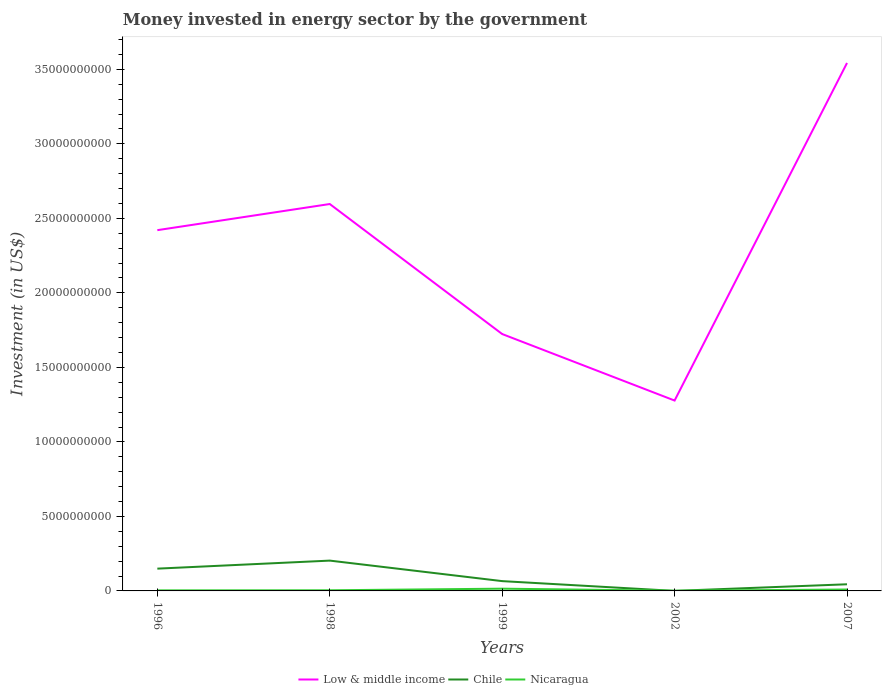How many different coloured lines are there?
Offer a very short reply. 3. Does the line corresponding to Chile intersect with the line corresponding to Nicaragua?
Provide a short and direct response. Yes. Across all years, what is the maximum money spent in energy sector in Low & middle income?
Give a very brief answer. 1.28e+1. What is the total money spent in energy sector in Low & middle income in the graph?
Provide a short and direct response. -1.75e+09. What is the difference between the highest and the second highest money spent in energy sector in Nicaragua?
Provide a short and direct response. 1.40e+08. What is the difference between the highest and the lowest money spent in energy sector in Nicaragua?
Keep it short and to the point. 2. How many lines are there?
Offer a very short reply. 3. What is the difference between two consecutive major ticks on the Y-axis?
Make the answer very short. 5.00e+09. Are the values on the major ticks of Y-axis written in scientific E-notation?
Ensure brevity in your answer.  No. Does the graph contain any zero values?
Your answer should be compact. No. Where does the legend appear in the graph?
Ensure brevity in your answer.  Bottom center. How are the legend labels stacked?
Your answer should be compact. Horizontal. What is the title of the graph?
Provide a succinct answer. Money invested in energy sector by the government. What is the label or title of the X-axis?
Provide a succinct answer. Years. What is the label or title of the Y-axis?
Provide a succinct answer. Investment (in US$). What is the Investment (in US$) of Low & middle income in 1996?
Make the answer very short. 2.42e+1. What is the Investment (in US$) in Chile in 1996?
Provide a succinct answer. 1.50e+09. What is the Investment (in US$) in Nicaragua in 1996?
Ensure brevity in your answer.  3.80e+07. What is the Investment (in US$) of Low & middle income in 1998?
Provide a succinct answer. 2.60e+1. What is the Investment (in US$) in Chile in 1998?
Give a very brief answer. 2.03e+09. What is the Investment (in US$) of Nicaragua in 1998?
Give a very brief answer. 4.30e+07. What is the Investment (in US$) in Low & middle income in 1999?
Your response must be concise. 1.72e+1. What is the Investment (in US$) in Chile in 1999?
Provide a succinct answer. 6.58e+08. What is the Investment (in US$) in Nicaragua in 1999?
Provide a short and direct response. 1.51e+08. What is the Investment (in US$) of Low & middle income in 2002?
Your response must be concise. 1.28e+1. What is the Investment (in US$) of Chile in 2002?
Make the answer very short. 1.90e+06. What is the Investment (in US$) of Nicaragua in 2002?
Offer a terse response. 1.13e+07. What is the Investment (in US$) in Low & middle income in 2007?
Ensure brevity in your answer.  3.54e+1. What is the Investment (in US$) of Chile in 2007?
Give a very brief answer. 4.46e+08. What is the Investment (in US$) in Nicaragua in 2007?
Make the answer very short. 9.50e+07. Across all years, what is the maximum Investment (in US$) of Low & middle income?
Ensure brevity in your answer.  3.54e+1. Across all years, what is the maximum Investment (in US$) in Chile?
Offer a very short reply. 2.03e+09. Across all years, what is the maximum Investment (in US$) of Nicaragua?
Offer a very short reply. 1.51e+08. Across all years, what is the minimum Investment (in US$) of Low & middle income?
Provide a succinct answer. 1.28e+1. Across all years, what is the minimum Investment (in US$) in Chile?
Give a very brief answer. 1.90e+06. Across all years, what is the minimum Investment (in US$) in Nicaragua?
Offer a very short reply. 1.13e+07. What is the total Investment (in US$) in Low & middle income in the graph?
Your answer should be very brief. 1.16e+11. What is the total Investment (in US$) of Chile in the graph?
Provide a short and direct response. 4.64e+09. What is the total Investment (in US$) in Nicaragua in the graph?
Your answer should be compact. 3.39e+08. What is the difference between the Investment (in US$) in Low & middle income in 1996 and that in 1998?
Offer a terse response. -1.75e+09. What is the difference between the Investment (in US$) of Chile in 1996 and that in 1998?
Your response must be concise. -5.40e+08. What is the difference between the Investment (in US$) in Nicaragua in 1996 and that in 1998?
Your answer should be compact. -5.00e+06. What is the difference between the Investment (in US$) of Low & middle income in 1996 and that in 1999?
Keep it short and to the point. 6.97e+09. What is the difference between the Investment (in US$) in Chile in 1996 and that in 1999?
Give a very brief answer. 8.37e+08. What is the difference between the Investment (in US$) in Nicaragua in 1996 and that in 1999?
Keep it short and to the point. -1.13e+08. What is the difference between the Investment (in US$) of Low & middle income in 1996 and that in 2002?
Offer a terse response. 1.14e+1. What is the difference between the Investment (in US$) in Chile in 1996 and that in 2002?
Ensure brevity in your answer.  1.49e+09. What is the difference between the Investment (in US$) of Nicaragua in 1996 and that in 2002?
Provide a succinct answer. 2.67e+07. What is the difference between the Investment (in US$) in Low & middle income in 1996 and that in 2007?
Your answer should be very brief. -1.12e+1. What is the difference between the Investment (in US$) of Chile in 1996 and that in 2007?
Your answer should be compact. 1.05e+09. What is the difference between the Investment (in US$) of Nicaragua in 1996 and that in 2007?
Your response must be concise. -5.70e+07. What is the difference between the Investment (in US$) of Low & middle income in 1998 and that in 1999?
Provide a short and direct response. 8.73e+09. What is the difference between the Investment (in US$) of Chile in 1998 and that in 1999?
Give a very brief answer. 1.38e+09. What is the difference between the Investment (in US$) of Nicaragua in 1998 and that in 1999?
Provide a short and direct response. -1.08e+08. What is the difference between the Investment (in US$) in Low & middle income in 1998 and that in 2002?
Provide a succinct answer. 1.32e+1. What is the difference between the Investment (in US$) in Chile in 1998 and that in 2002?
Offer a terse response. 2.03e+09. What is the difference between the Investment (in US$) of Nicaragua in 1998 and that in 2002?
Ensure brevity in your answer.  3.17e+07. What is the difference between the Investment (in US$) in Low & middle income in 1998 and that in 2007?
Ensure brevity in your answer.  -9.47e+09. What is the difference between the Investment (in US$) in Chile in 1998 and that in 2007?
Your response must be concise. 1.59e+09. What is the difference between the Investment (in US$) in Nicaragua in 1998 and that in 2007?
Provide a succinct answer. -5.20e+07. What is the difference between the Investment (in US$) in Low & middle income in 1999 and that in 2002?
Ensure brevity in your answer.  4.46e+09. What is the difference between the Investment (in US$) in Chile in 1999 and that in 2002?
Your response must be concise. 6.56e+08. What is the difference between the Investment (in US$) of Nicaragua in 1999 and that in 2002?
Give a very brief answer. 1.40e+08. What is the difference between the Investment (in US$) in Low & middle income in 1999 and that in 2007?
Ensure brevity in your answer.  -1.82e+1. What is the difference between the Investment (in US$) of Chile in 1999 and that in 2007?
Ensure brevity in your answer.  2.12e+08. What is the difference between the Investment (in US$) of Nicaragua in 1999 and that in 2007?
Your answer should be very brief. 5.64e+07. What is the difference between the Investment (in US$) in Low & middle income in 2002 and that in 2007?
Provide a short and direct response. -2.27e+1. What is the difference between the Investment (in US$) of Chile in 2002 and that in 2007?
Provide a succinct answer. -4.44e+08. What is the difference between the Investment (in US$) in Nicaragua in 2002 and that in 2007?
Provide a short and direct response. -8.37e+07. What is the difference between the Investment (in US$) of Low & middle income in 1996 and the Investment (in US$) of Chile in 1998?
Give a very brief answer. 2.22e+1. What is the difference between the Investment (in US$) in Low & middle income in 1996 and the Investment (in US$) in Nicaragua in 1998?
Your answer should be very brief. 2.42e+1. What is the difference between the Investment (in US$) in Chile in 1996 and the Investment (in US$) in Nicaragua in 1998?
Keep it short and to the point. 1.45e+09. What is the difference between the Investment (in US$) of Low & middle income in 1996 and the Investment (in US$) of Chile in 1999?
Give a very brief answer. 2.36e+1. What is the difference between the Investment (in US$) in Low & middle income in 1996 and the Investment (in US$) in Nicaragua in 1999?
Your answer should be very brief. 2.41e+1. What is the difference between the Investment (in US$) of Chile in 1996 and the Investment (in US$) of Nicaragua in 1999?
Give a very brief answer. 1.34e+09. What is the difference between the Investment (in US$) of Low & middle income in 1996 and the Investment (in US$) of Chile in 2002?
Your answer should be very brief. 2.42e+1. What is the difference between the Investment (in US$) of Low & middle income in 1996 and the Investment (in US$) of Nicaragua in 2002?
Offer a very short reply. 2.42e+1. What is the difference between the Investment (in US$) of Chile in 1996 and the Investment (in US$) of Nicaragua in 2002?
Your response must be concise. 1.48e+09. What is the difference between the Investment (in US$) of Low & middle income in 1996 and the Investment (in US$) of Chile in 2007?
Your answer should be compact. 2.38e+1. What is the difference between the Investment (in US$) in Low & middle income in 1996 and the Investment (in US$) in Nicaragua in 2007?
Your answer should be very brief. 2.41e+1. What is the difference between the Investment (in US$) of Chile in 1996 and the Investment (in US$) of Nicaragua in 2007?
Your answer should be very brief. 1.40e+09. What is the difference between the Investment (in US$) in Low & middle income in 1998 and the Investment (in US$) in Chile in 1999?
Your answer should be very brief. 2.53e+1. What is the difference between the Investment (in US$) in Low & middle income in 1998 and the Investment (in US$) in Nicaragua in 1999?
Give a very brief answer. 2.58e+1. What is the difference between the Investment (in US$) in Chile in 1998 and the Investment (in US$) in Nicaragua in 1999?
Your response must be concise. 1.88e+09. What is the difference between the Investment (in US$) of Low & middle income in 1998 and the Investment (in US$) of Chile in 2002?
Your response must be concise. 2.60e+1. What is the difference between the Investment (in US$) of Low & middle income in 1998 and the Investment (in US$) of Nicaragua in 2002?
Your response must be concise. 2.60e+1. What is the difference between the Investment (in US$) of Chile in 1998 and the Investment (in US$) of Nicaragua in 2002?
Your answer should be compact. 2.02e+09. What is the difference between the Investment (in US$) of Low & middle income in 1998 and the Investment (in US$) of Chile in 2007?
Your answer should be very brief. 2.55e+1. What is the difference between the Investment (in US$) in Low & middle income in 1998 and the Investment (in US$) in Nicaragua in 2007?
Your response must be concise. 2.59e+1. What is the difference between the Investment (in US$) in Chile in 1998 and the Investment (in US$) in Nicaragua in 2007?
Keep it short and to the point. 1.94e+09. What is the difference between the Investment (in US$) in Low & middle income in 1999 and the Investment (in US$) in Chile in 2002?
Ensure brevity in your answer.  1.72e+1. What is the difference between the Investment (in US$) in Low & middle income in 1999 and the Investment (in US$) in Nicaragua in 2002?
Your answer should be very brief. 1.72e+1. What is the difference between the Investment (in US$) in Chile in 1999 and the Investment (in US$) in Nicaragua in 2002?
Ensure brevity in your answer.  6.46e+08. What is the difference between the Investment (in US$) of Low & middle income in 1999 and the Investment (in US$) of Chile in 2007?
Give a very brief answer. 1.68e+1. What is the difference between the Investment (in US$) in Low & middle income in 1999 and the Investment (in US$) in Nicaragua in 2007?
Offer a very short reply. 1.71e+1. What is the difference between the Investment (in US$) in Chile in 1999 and the Investment (in US$) in Nicaragua in 2007?
Provide a short and direct response. 5.63e+08. What is the difference between the Investment (in US$) in Low & middle income in 2002 and the Investment (in US$) in Chile in 2007?
Provide a short and direct response. 1.23e+1. What is the difference between the Investment (in US$) in Low & middle income in 2002 and the Investment (in US$) in Nicaragua in 2007?
Your response must be concise. 1.27e+1. What is the difference between the Investment (in US$) of Chile in 2002 and the Investment (in US$) of Nicaragua in 2007?
Provide a short and direct response. -9.31e+07. What is the average Investment (in US$) of Low & middle income per year?
Your answer should be very brief. 2.31e+1. What is the average Investment (in US$) of Chile per year?
Your answer should be very brief. 9.27e+08. What is the average Investment (in US$) of Nicaragua per year?
Ensure brevity in your answer.  6.77e+07. In the year 1996, what is the difference between the Investment (in US$) of Low & middle income and Investment (in US$) of Chile?
Your answer should be very brief. 2.27e+1. In the year 1996, what is the difference between the Investment (in US$) in Low & middle income and Investment (in US$) in Nicaragua?
Ensure brevity in your answer.  2.42e+1. In the year 1996, what is the difference between the Investment (in US$) in Chile and Investment (in US$) in Nicaragua?
Your response must be concise. 1.46e+09. In the year 1998, what is the difference between the Investment (in US$) of Low & middle income and Investment (in US$) of Chile?
Ensure brevity in your answer.  2.39e+1. In the year 1998, what is the difference between the Investment (in US$) of Low & middle income and Investment (in US$) of Nicaragua?
Ensure brevity in your answer.  2.59e+1. In the year 1998, what is the difference between the Investment (in US$) in Chile and Investment (in US$) in Nicaragua?
Offer a very short reply. 1.99e+09. In the year 1999, what is the difference between the Investment (in US$) in Low & middle income and Investment (in US$) in Chile?
Your response must be concise. 1.66e+1. In the year 1999, what is the difference between the Investment (in US$) of Low & middle income and Investment (in US$) of Nicaragua?
Offer a terse response. 1.71e+1. In the year 1999, what is the difference between the Investment (in US$) in Chile and Investment (in US$) in Nicaragua?
Offer a terse response. 5.06e+08. In the year 2002, what is the difference between the Investment (in US$) in Low & middle income and Investment (in US$) in Chile?
Ensure brevity in your answer.  1.28e+1. In the year 2002, what is the difference between the Investment (in US$) of Low & middle income and Investment (in US$) of Nicaragua?
Provide a succinct answer. 1.28e+1. In the year 2002, what is the difference between the Investment (in US$) in Chile and Investment (in US$) in Nicaragua?
Offer a very short reply. -9.40e+06. In the year 2007, what is the difference between the Investment (in US$) in Low & middle income and Investment (in US$) in Chile?
Offer a terse response. 3.50e+1. In the year 2007, what is the difference between the Investment (in US$) in Low & middle income and Investment (in US$) in Nicaragua?
Give a very brief answer. 3.53e+1. In the year 2007, what is the difference between the Investment (in US$) of Chile and Investment (in US$) of Nicaragua?
Give a very brief answer. 3.51e+08. What is the ratio of the Investment (in US$) in Low & middle income in 1996 to that in 1998?
Provide a short and direct response. 0.93. What is the ratio of the Investment (in US$) of Chile in 1996 to that in 1998?
Provide a short and direct response. 0.73. What is the ratio of the Investment (in US$) of Nicaragua in 1996 to that in 1998?
Provide a short and direct response. 0.88. What is the ratio of the Investment (in US$) in Low & middle income in 1996 to that in 1999?
Keep it short and to the point. 1.4. What is the ratio of the Investment (in US$) of Chile in 1996 to that in 1999?
Give a very brief answer. 2.27. What is the ratio of the Investment (in US$) in Nicaragua in 1996 to that in 1999?
Provide a succinct answer. 0.25. What is the ratio of the Investment (in US$) in Low & middle income in 1996 to that in 2002?
Your answer should be very brief. 1.89. What is the ratio of the Investment (in US$) in Chile in 1996 to that in 2002?
Make the answer very short. 786.84. What is the ratio of the Investment (in US$) in Nicaragua in 1996 to that in 2002?
Your answer should be very brief. 3.36. What is the ratio of the Investment (in US$) in Low & middle income in 1996 to that in 2007?
Give a very brief answer. 0.68. What is the ratio of the Investment (in US$) in Chile in 1996 to that in 2007?
Your answer should be compact. 3.35. What is the ratio of the Investment (in US$) of Nicaragua in 1996 to that in 2007?
Provide a succinct answer. 0.4. What is the ratio of the Investment (in US$) in Low & middle income in 1998 to that in 1999?
Your response must be concise. 1.51. What is the ratio of the Investment (in US$) of Chile in 1998 to that in 1999?
Keep it short and to the point. 3.09. What is the ratio of the Investment (in US$) in Nicaragua in 1998 to that in 1999?
Keep it short and to the point. 0.28. What is the ratio of the Investment (in US$) of Low & middle income in 1998 to that in 2002?
Your answer should be very brief. 2.03. What is the ratio of the Investment (in US$) of Chile in 1998 to that in 2002?
Your response must be concise. 1070.84. What is the ratio of the Investment (in US$) in Nicaragua in 1998 to that in 2002?
Provide a succinct answer. 3.81. What is the ratio of the Investment (in US$) in Low & middle income in 1998 to that in 2007?
Provide a succinct answer. 0.73. What is the ratio of the Investment (in US$) of Chile in 1998 to that in 2007?
Offer a very short reply. 4.56. What is the ratio of the Investment (in US$) of Nicaragua in 1998 to that in 2007?
Ensure brevity in your answer.  0.45. What is the ratio of the Investment (in US$) in Low & middle income in 1999 to that in 2002?
Your answer should be very brief. 1.35. What is the ratio of the Investment (in US$) in Chile in 1999 to that in 2002?
Your answer should be very brief. 346.16. What is the ratio of the Investment (in US$) of Nicaragua in 1999 to that in 2002?
Keep it short and to the point. 13.4. What is the ratio of the Investment (in US$) of Low & middle income in 1999 to that in 2007?
Offer a terse response. 0.49. What is the ratio of the Investment (in US$) of Chile in 1999 to that in 2007?
Make the answer very short. 1.47. What is the ratio of the Investment (in US$) of Nicaragua in 1999 to that in 2007?
Your answer should be very brief. 1.59. What is the ratio of the Investment (in US$) of Low & middle income in 2002 to that in 2007?
Make the answer very short. 0.36. What is the ratio of the Investment (in US$) in Chile in 2002 to that in 2007?
Ensure brevity in your answer.  0. What is the ratio of the Investment (in US$) of Nicaragua in 2002 to that in 2007?
Give a very brief answer. 0.12. What is the difference between the highest and the second highest Investment (in US$) of Low & middle income?
Your answer should be very brief. 9.47e+09. What is the difference between the highest and the second highest Investment (in US$) in Chile?
Your response must be concise. 5.40e+08. What is the difference between the highest and the second highest Investment (in US$) of Nicaragua?
Your answer should be very brief. 5.64e+07. What is the difference between the highest and the lowest Investment (in US$) in Low & middle income?
Your answer should be compact. 2.27e+1. What is the difference between the highest and the lowest Investment (in US$) of Chile?
Give a very brief answer. 2.03e+09. What is the difference between the highest and the lowest Investment (in US$) of Nicaragua?
Give a very brief answer. 1.40e+08. 